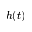<formula> <loc_0><loc_0><loc_500><loc_500>h ( t )</formula> 